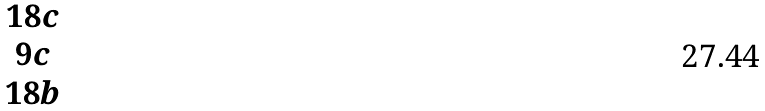Convert formula to latex. <formula><loc_0><loc_0><loc_500><loc_500>\begin{matrix} 1 8 c \\ 9 c \\ 1 8 b \end{matrix}</formula> 